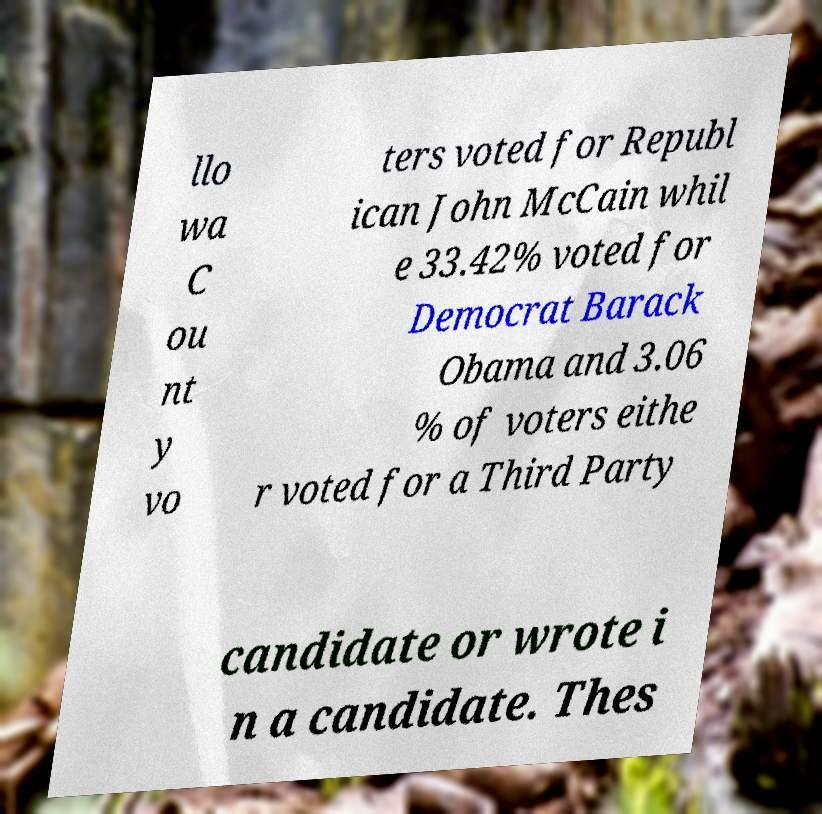Could you assist in decoding the text presented in this image and type it out clearly? llo wa C ou nt y vo ters voted for Republ ican John McCain whil e 33.42% voted for Democrat Barack Obama and 3.06 % of voters eithe r voted for a Third Party candidate or wrote i n a candidate. Thes 